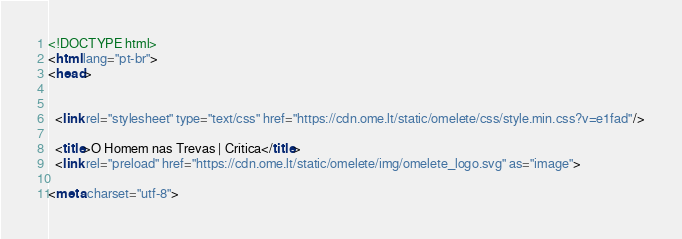<code> <loc_0><loc_0><loc_500><loc_500><_HTML_>

<!DOCTYPE html>
<html lang="pt-br">
<head>
  

  <link rel="stylesheet" type="text/css" href="https://cdn.ome.lt/static/omelete/css/style.min.css?v=e1fad"/>

  <title>O Homem nas Trevas | Crítica</title>
  <link rel="preload" href="https://cdn.ome.lt/static/omelete/img/omelete_logo.svg" as="image">

<meta charset="utf-8"></code> 